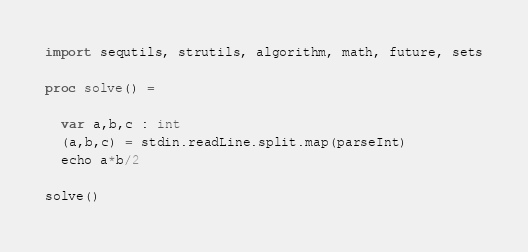Convert code to text. <code><loc_0><loc_0><loc_500><loc_500><_Nim_>import sequtils, strutils, algorithm, math, future, sets

proc solve() =

  var a,b,c : int
  (a,b,c) = stdin.readLine.split.map(parseInt)
  echo a*b/2

solve()</code> 